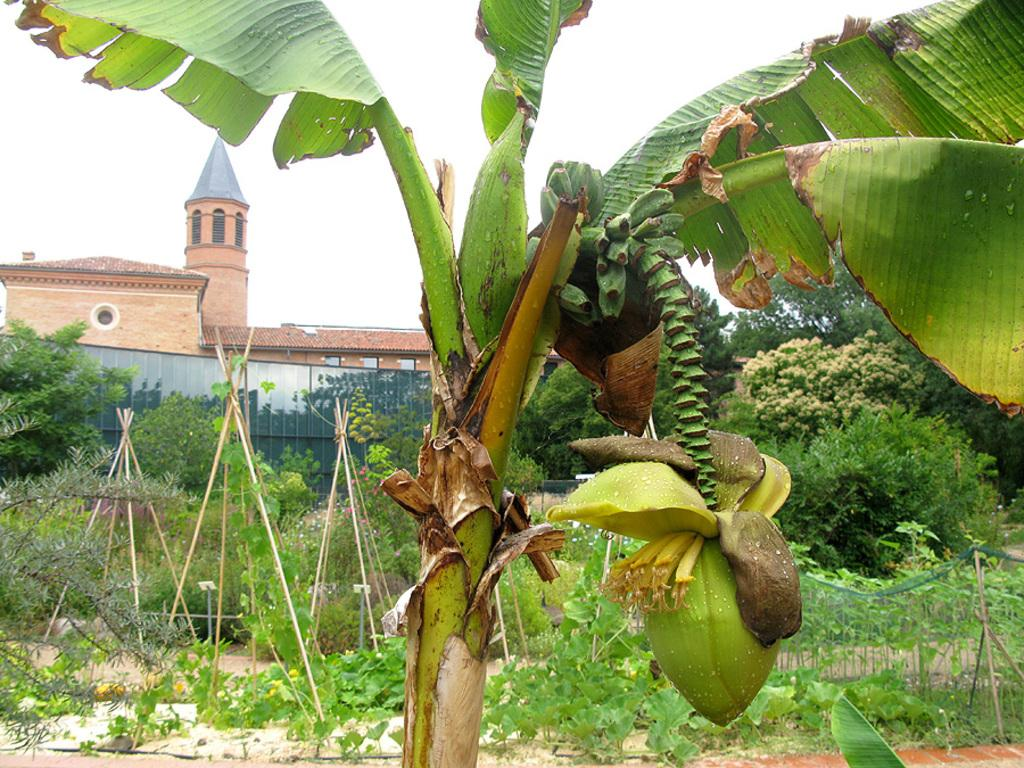What type of tree is in the image? There is a coconut tree in the image. What can be seen behind the coconut tree? Bamboos, plants, and trees are visible behind the tree. What type of barrier is in the image? There is fencing in the image. What type of structure is in the image? There is a building in the image. What is the color of the sky in the image? The sky is white in color. How many books are stacked on the coconut tree in the image? There are no books present in the image, as it features a coconut tree, bamboos, plants, trees, fencing, a building, and a white sky. 